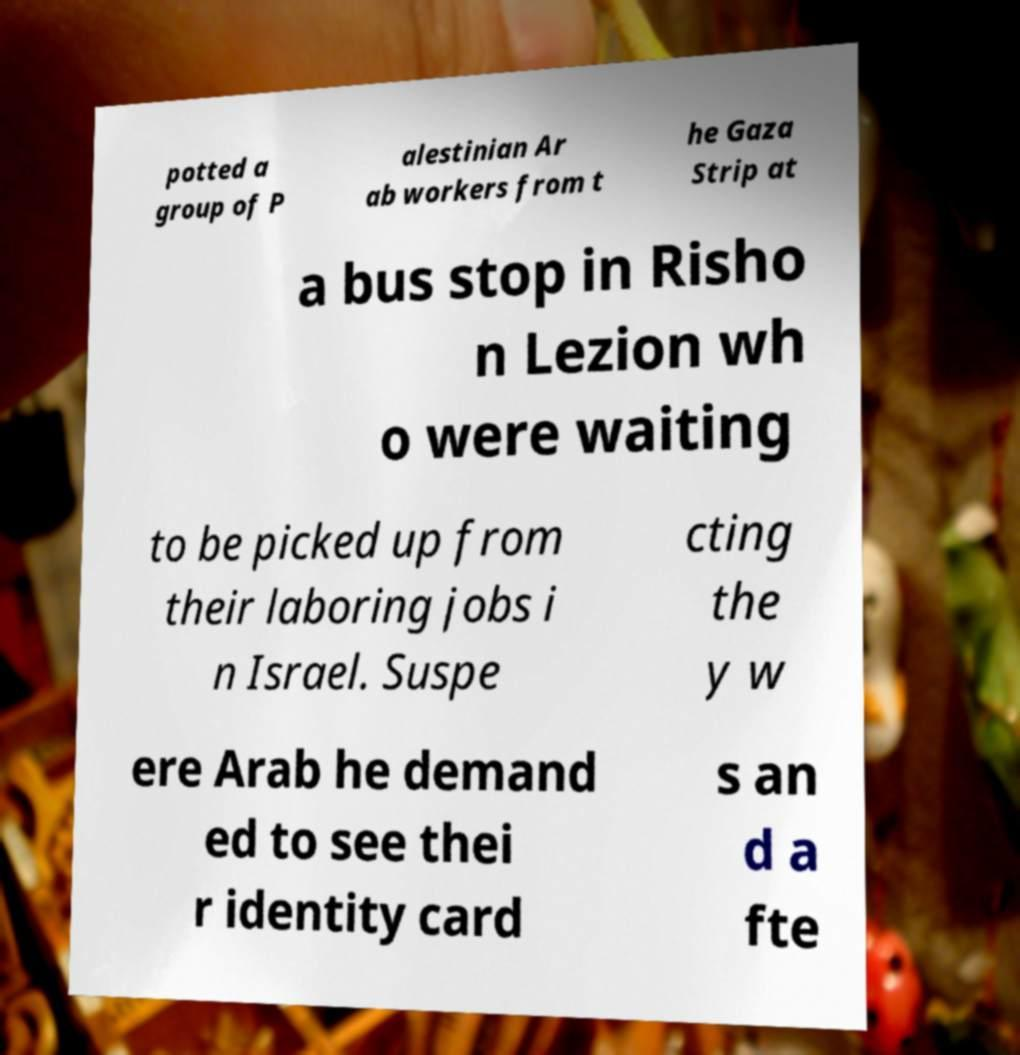Please read and relay the text visible in this image. What does it say? potted a group of P alestinian Ar ab workers from t he Gaza Strip at a bus stop in Risho n Lezion wh o were waiting to be picked up from their laboring jobs i n Israel. Suspe cting the y w ere Arab he demand ed to see thei r identity card s an d a fte 